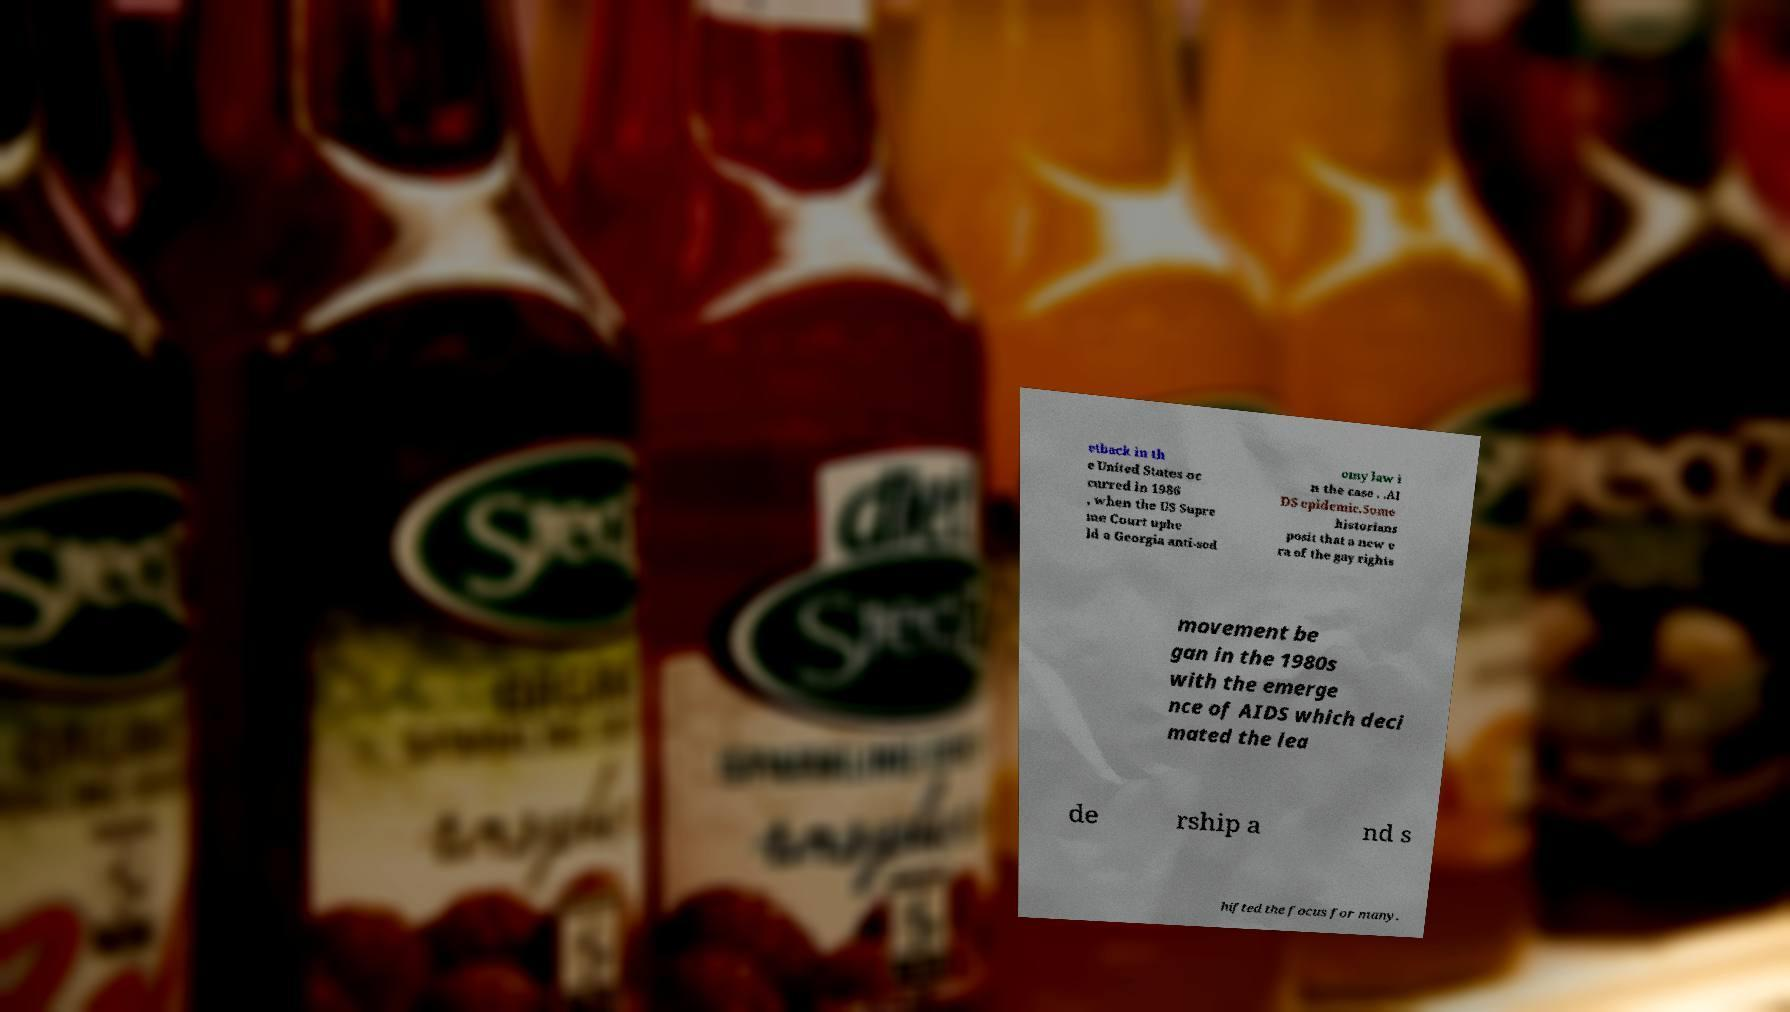Can you read and provide the text displayed in the image?This photo seems to have some interesting text. Can you extract and type it out for me? etback in th e United States oc curred in 1986 , when the US Supre me Court uphe ld a Georgia anti-sod omy law i n the case . .AI DS epidemic.Some historians posit that a new e ra of the gay rights movement be gan in the 1980s with the emerge nce of AIDS which deci mated the lea de rship a nd s hifted the focus for many. 